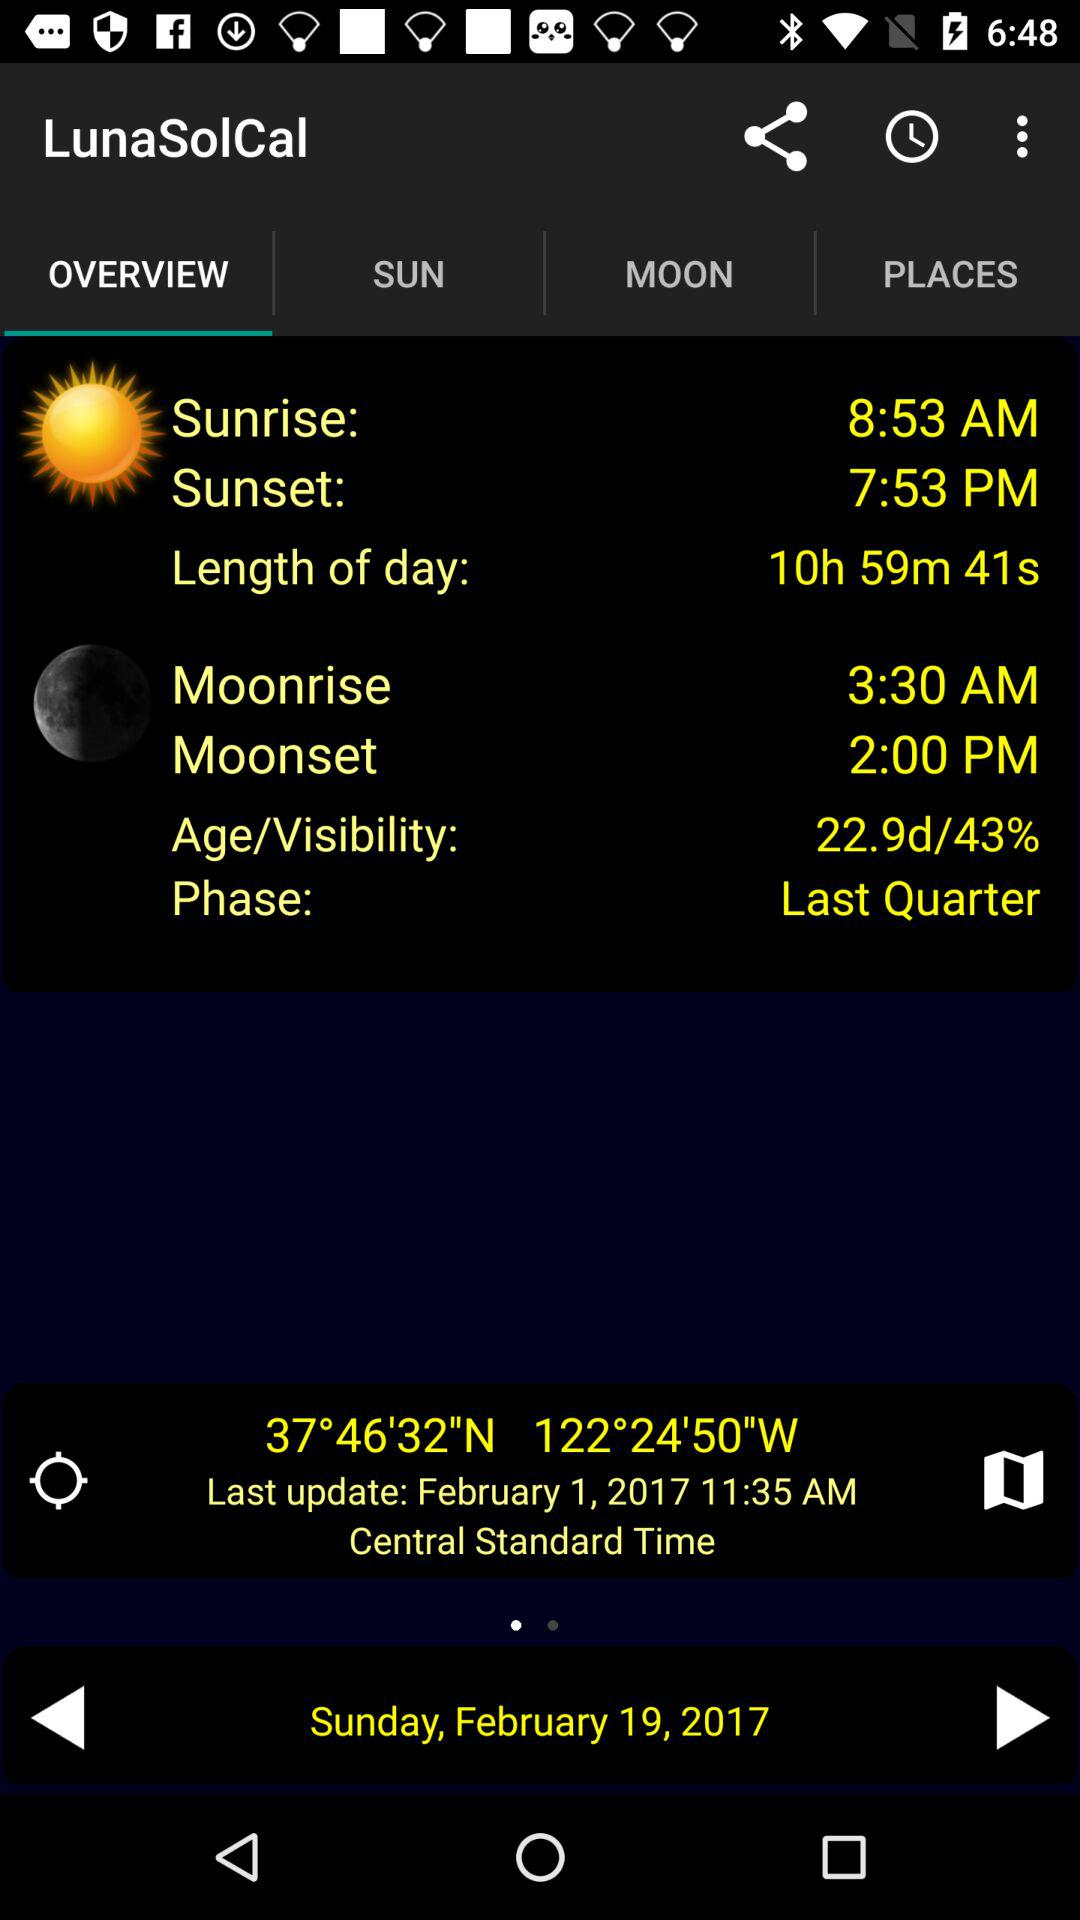What is the mentioned date? The mentioned date is February 19, 2017. 